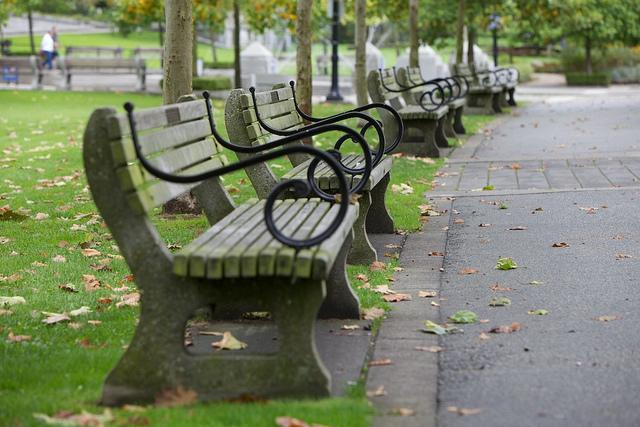What is on the grass? Please explain your reasoning. bench. There are seats. 